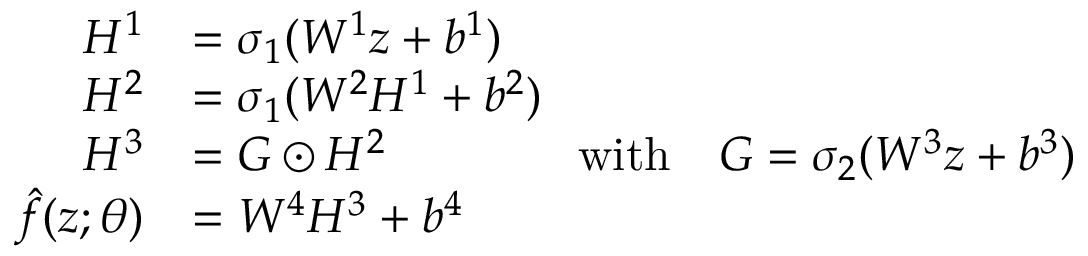<formula> <loc_0><loc_0><loc_500><loc_500>\begin{array} { r l } { H ^ { 1 } } & { = \sigma _ { 1 } ( W ^ { 1 } z + b ^ { 1 } ) } \\ { H ^ { 2 } } & { = \sigma _ { 1 } ( W ^ { 2 } H ^ { 1 } + b ^ { 2 } ) } \\ { H ^ { 3 } } & { = G \odot H ^ { 2 } \quad w i t h \quad G = \sigma _ { 2 } ( W ^ { 3 } z + b ^ { 3 } ) } \\ { \hat { f } ( z ; { \theta } ) } & { = W ^ { 4 } H ^ { 3 } + b ^ { 4 } } \end{array}</formula> 